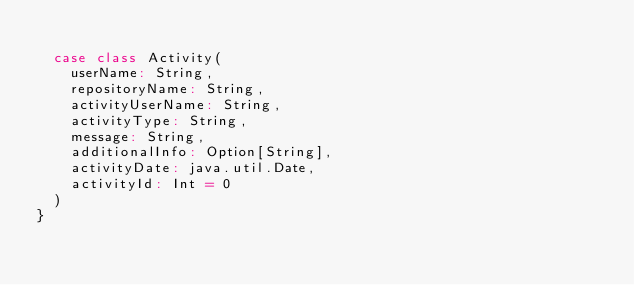Convert code to text. <code><loc_0><loc_0><loc_500><loc_500><_Scala_>
  case class Activity(
    userName: String,
    repositoryName: String,
    activityUserName: String,
    activityType: String,
    message: String,
    additionalInfo: Option[String],
    activityDate: java.util.Date,
    activityId: Int = 0
  )
}
</code> 